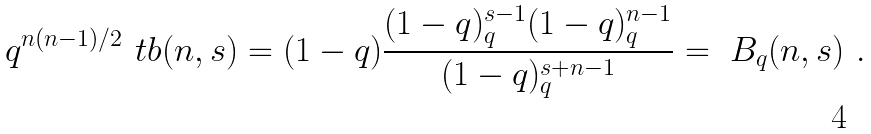Convert formula to latex. <formula><loc_0><loc_0><loc_500><loc_500>q ^ { n ( n - 1 ) / 2 } \ t b ( n , s ) = ( 1 - q ) \frac { ( 1 - q ) _ { q } ^ { s - 1 } ( 1 - q ) _ { q } ^ { n - 1 } } { ( 1 - q ) _ { q } ^ { s + n - 1 } } = \ B _ { q } ( n , s ) \ .</formula> 